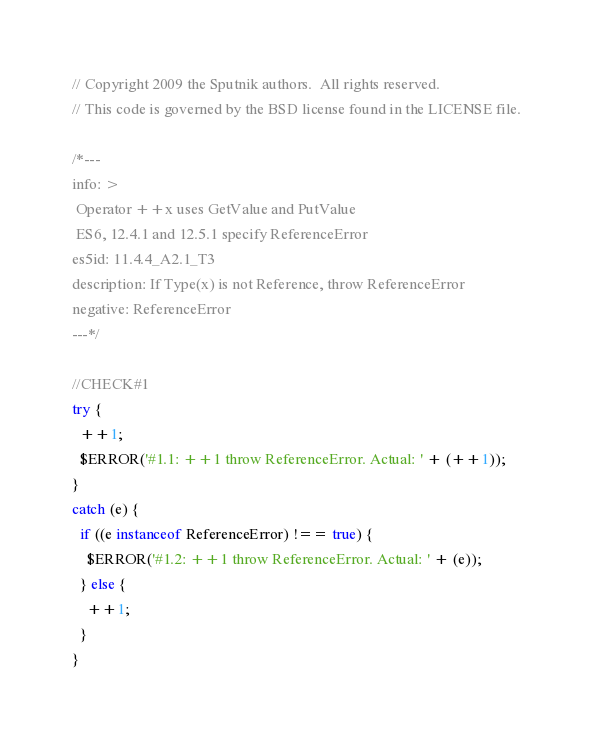<code> <loc_0><loc_0><loc_500><loc_500><_JavaScript_>// Copyright 2009 the Sputnik authors.  All rights reserved.
// This code is governed by the BSD license found in the LICENSE file.

/*---
info: >
 Operator ++x uses GetValue and PutValue
 ES6, 12.4.1 and 12.5.1 specify ReferenceError
es5id: 11.4.4_A2.1_T3
description: If Type(x) is not Reference, throw ReferenceError
negative: ReferenceError
---*/

//CHECK#1
try {
  ++1;
  $ERROR('#1.1: ++1 throw ReferenceError. Actual: ' + (++1));  
}
catch (e) {
  if ((e instanceof ReferenceError) !== true) {
    $ERROR('#1.2: ++1 throw ReferenceError. Actual: ' + (e));  
  } else {
    ++1;
  }
}
</code> 